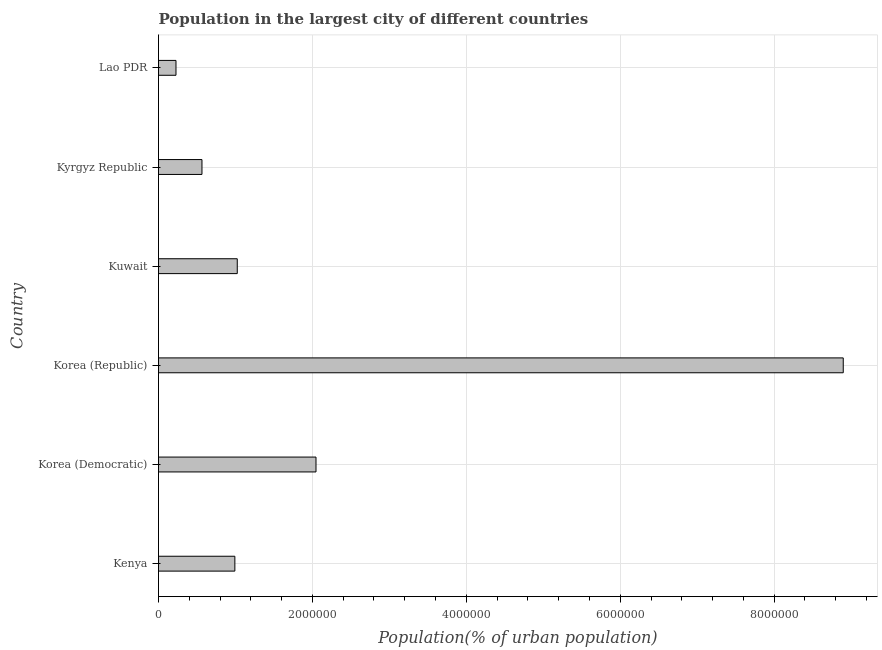What is the title of the graph?
Your answer should be compact. Population in the largest city of different countries. What is the label or title of the X-axis?
Make the answer very short. Population(% of urban population). What is the label or title of the Y-axis?
Your response must be concise. Country. What is the population in largest city in Korea (Democratic)?
Make the answer very short. 2.05e+06. Across all countries, what is the maximum population in largest city?
Make the answer very short. 8.90e+06. Across all countries, what is the minimum population in largest city?
Provide a short and direct response. 2.27e+05. In which country was the population in largest city minimum?
Give a very brief answer. Lao PDR. What is the sum of the population in largest city?
Provide a short and direct response. 1.38e+07. What is the difference between the population in largest city in Kenya and Lao PDR?
Provide a succinct answer. 7.65e+05. What is the average population in largest city per country?
Your answer should be very brief. 2.29e+06. What is the median population in largest city?
Provide a short and direct response. 1.01e+06. What is the ratio of the population in largest city in Kyrgyz Republic to that in Lao PDR?
Keep it short and to the point. 2.49. Is the population in largest city in Korea (Republic) less than that in Lao PDR?
Your answer should be very brief. No. What is the difference between the highest and the second highest population in largest city?
Keep it short and to the point. 6.85e+06. What is the difference between the highest and the lowest population in largest city?
Give a very brief answer. 8.67e+06. How many bars are there?
Keep it short and to the point. 6. Are all the bars in the graph horizontal?
Offer a terse response. Yes. How many countries are there in the graph?
Provide a succinct answer. 6. What is the difference between two consecutive major ticks on the X-axis?
Give a very brief answer. 2.00e+06. Are the values on the major ticks of X-axis written in scientific E-notation?
Offer a very short reply. No. What is the Population(% of urban population) in Kenya?
Offer a very short reply. 9.92e+05. What is the Population(% of urban population) of Korea (Democratic)?
Your response must be concise. 2.05e+06. What is the Population(% of urban population) of Korea (Republic)?
Offer a very short reply. 8.90e+06. What is the Population(% of urban population) in Kuwait?
Make the answer very short. 1.02e+06. What is the Population(% of urban population) of Kyrgyz Republic?
Make the answer very short. 5.65e+05. What is the Population(% of urban population) in Lao PDR?
Ensure brevity in your answer.  2.27e+05. What is the difference between the Population(% of urban population) in Kenya and Korea (Democratic)?
Give a very brief answer. -1.05e+06. What is the difference between the Population(% of urban population) in Kenya and Korea (Republic)?
Keep it short and to the point. -7.91e+06. What is the difference between the Population(% of urban population) in Kenya and Kuwait?
Your answer should be compact. -3.13e+04. What is the difference between the Population(% of urban population) in Kenya and Kyrgyz Republic?
Offer a very short reply. 4.27e+05. What is the difference between the Population(% of urban population) in Kenya and Lao PDR?
Make the answer very short. 7.65e+05. What is the difference between the Population(% of urban population) in Korea (Democratic) and Korea (Republic)?
Keep it short and to the point. -6.85e+06. What is the difference between the Population(% of urban population) in Korea (Democratic) and Kuwait?
Your answer should be compact. 1.02e+06. What is the difference between the Population(% of urban population) in Korea (Democratic) and Kyrgyz Republic?
Provide a succinct answer. 1.48e+06. What is the difference between the Population(% of urban population) in Korea (Democratic) and Lao PDR?
Make the answer very short. 1.82e+06. What is the difference between the Population(% of urban population) in Korea (Republic) and Kuwait?
Ensure brevity in your answer.  7.87e+06. What is the difference between the Population(% of urban population) in Korea (Republic) and Kyrgyz Republic?
Give a very brief answer. 8.33e+06. What is the difference between the Population(% of urban population) in Korea (Republic) and Lao PDR?
Offer a terse response. 8.67e+06. What is the difference between the Population(% of urban population) in Kuwait and Kyrgyz Republic?
Ensure brevity in your answer.  4.59e+05. What is the difference between the Population(% of urban population) in Kuwait and Lao PDR?
Provide a short and direct response. 7.96e+05. What is the difference between the Population(% of urban population) in Kyrgyz Republic and Lao PDR?
Offer a very short reply. 3.38e+05. What is the ratio of the Population(% of urban population) in Kenya to that in Korea (Democratic)?
Your answer should be compact. 0.48. What is the ratio of the Population(% of urban population) in Kenya to that in Korea (Republic)?
Your response must be concise. 0.11. What is the ratio of the Population(% of urban population) in Kenya to that in Kuwait?
Your response must be concise. 0.97. What is the ratio of the Population(% of urban population) in Kenya to that in Kyrgyz Republic?
Ensure brevity in your answer.  1.76. What is the ratio of the Population(% of urban population) in Kenya to that in Lao PDR?
Offer a very short reply. 4.37. What is the ratio of the Population(% of urban population) in Korea (Democratic) to that in Korea (Republic)?
Make the answer very short. 0.23. What is the ratio of the Population(% of urban population) in Korea (Democratic) to that in Kyrgyz Republic?
Keep it short and to the point. 3.62. What is the ratio of the Population(% of urban population) in Korea (Democratic) to that in Lao PDR?
Give a very brief answer. 9.02. What is the ratio of the Population(% of urban population) in Korea (Republic) to that in Kuwait?
Your answer should be compact. 8.7. What is the ratio of the Population(% of urban population) in Korea (Republic) to that in Kyrgyz Republic?
Your answer should be very brief. 15.76. What is the ratio of the Population(% of urban population) in Korea (Republic) to that in Lao PDR?
Your answer should be very brief. 39.2. What is the ratio of the Population(% of urban population) in Kuwait to that in Kyrgyz Republic?
Give a very brief answer. 1.81. What is the ratio of the Population(% of urban population) in Kuwait to that in Lao PDR?
Ensure brevity in your answer.  4.51. What is the ratio of the Population(% of urban population) in Kyrgyz Republic to that in Lao PDR?
Offer a very short reply. 2.49. 